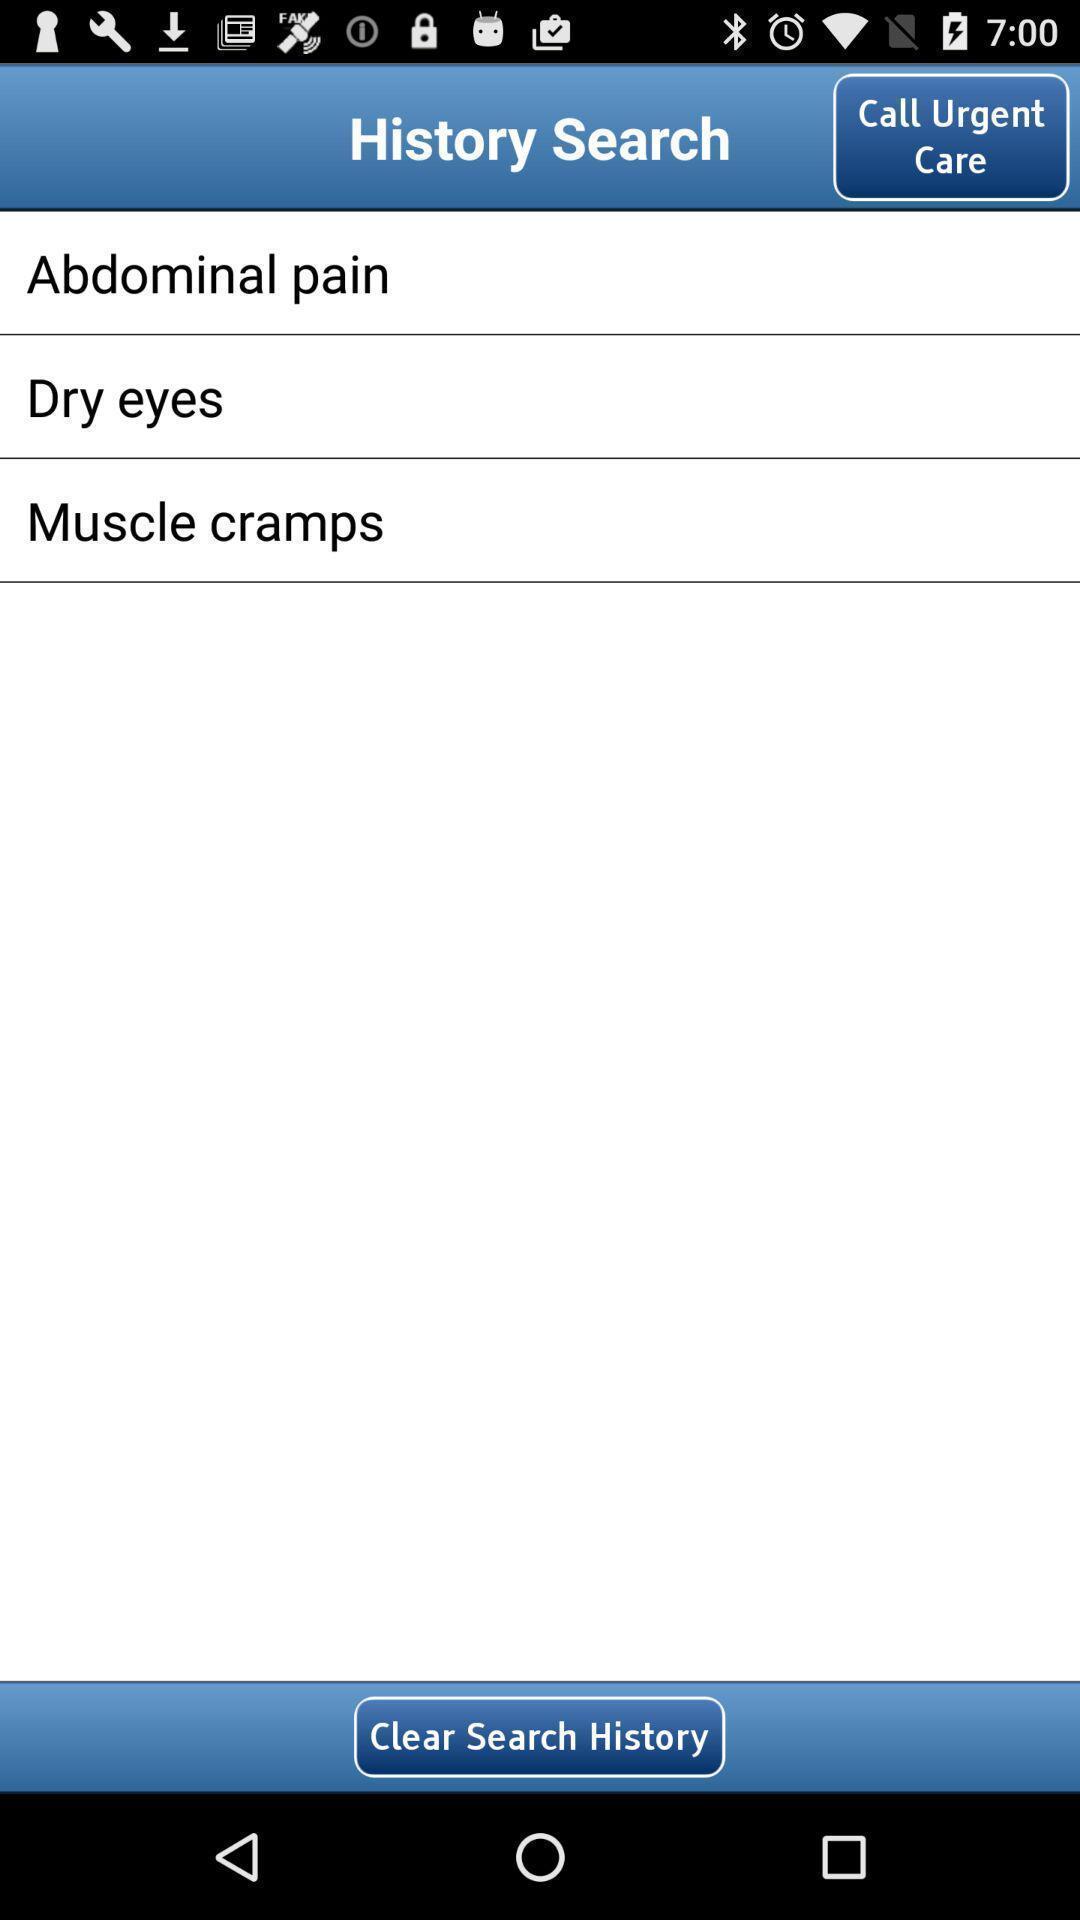Give me a narrative description of this picture. Social app for searching history. 